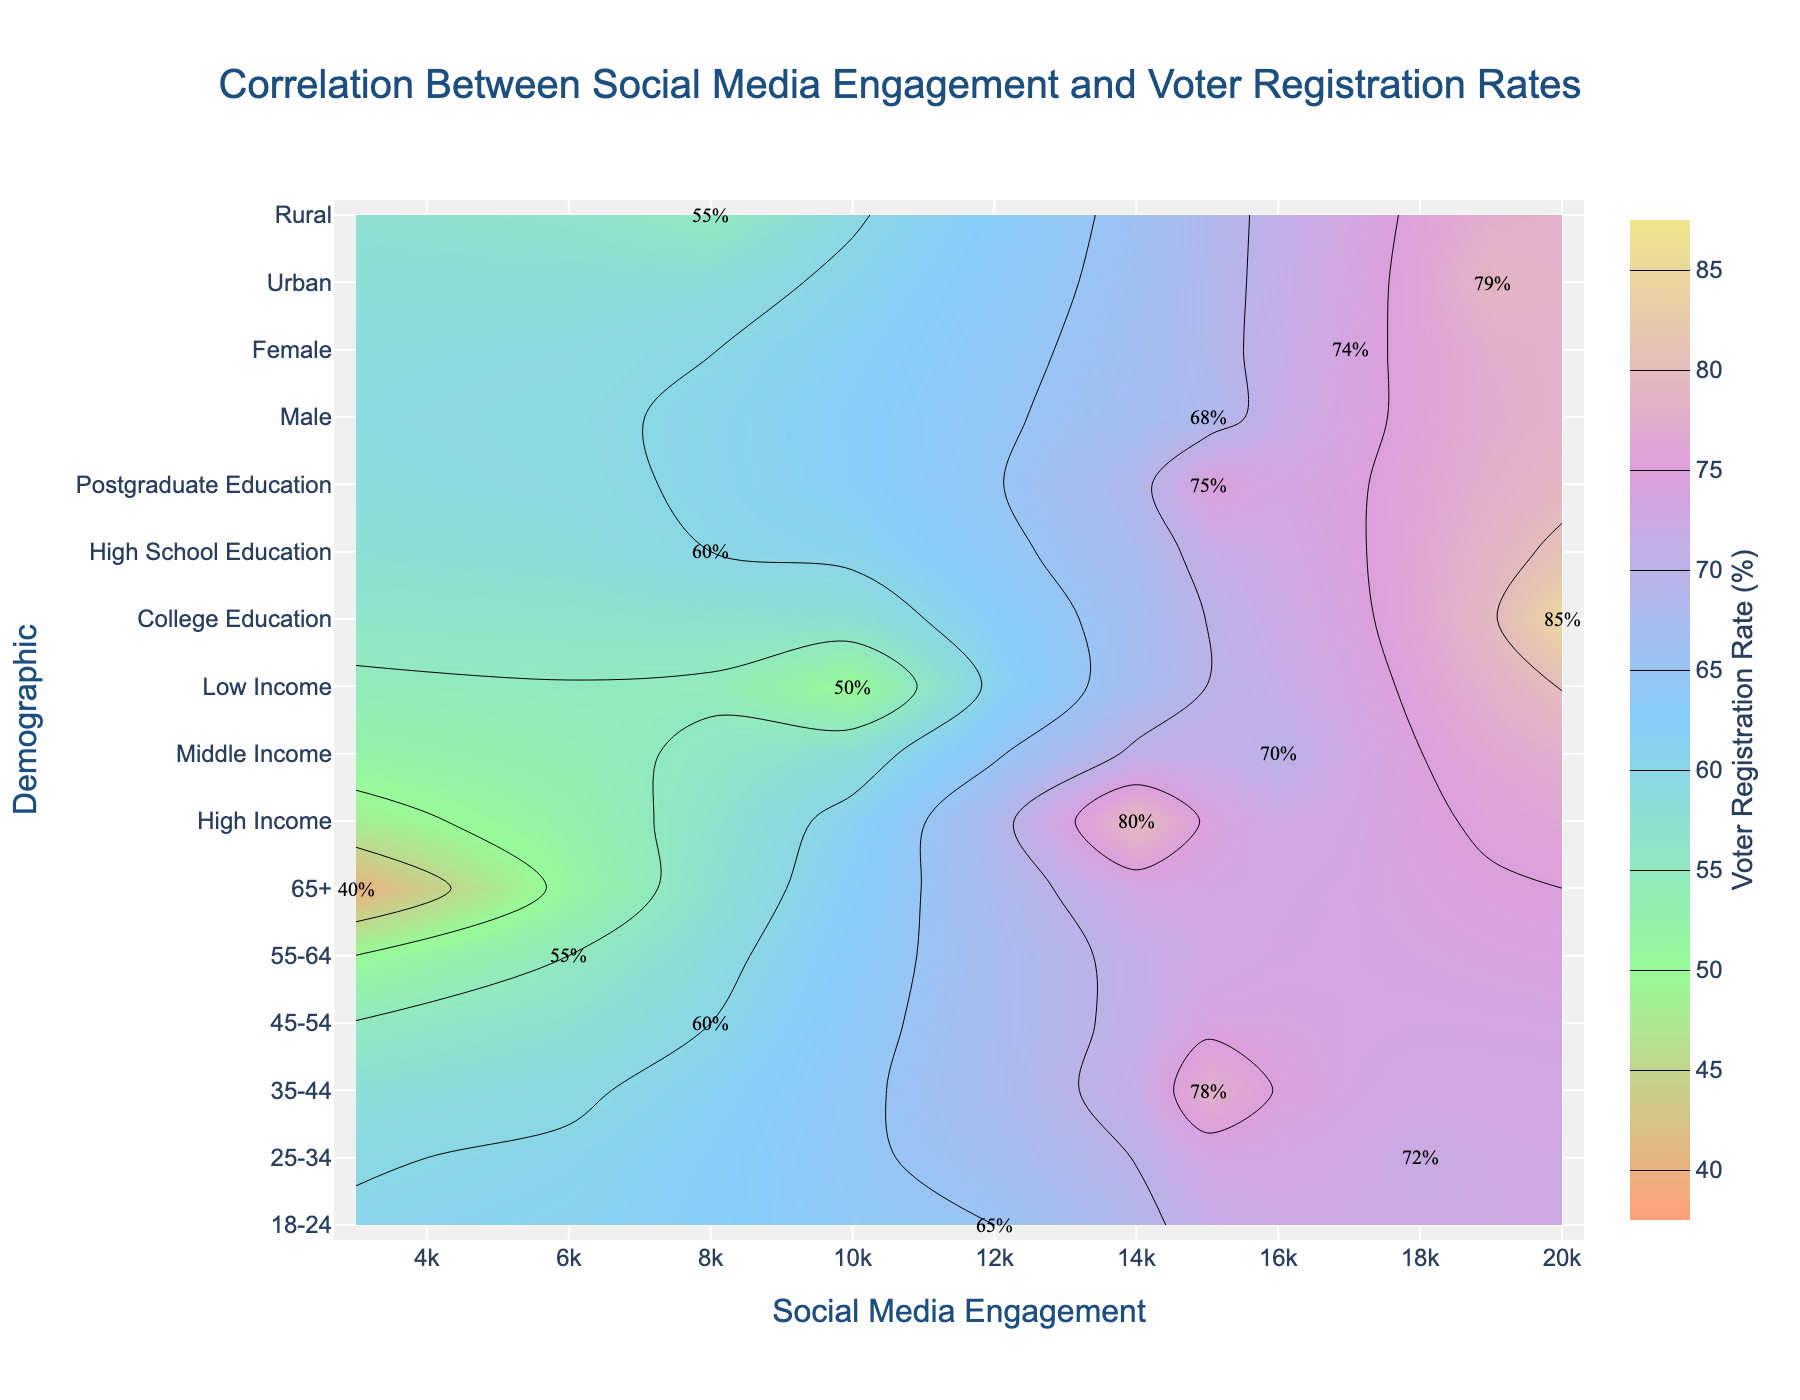What's the title of the figure? The title typically appears at the top of the figure to describe the main purpose of the plot. Here, the title is clearly placed above the plot area.
Answer: Correlation Between Social Media Engagement and Voter Registration Rates What is the color range used in the contour plot? The contour plot uses a set of colors to represent different ranges of voter registration rates, extending from light colors to dark colors to portrait the rate differences. The colors used range from light pink to light purple.
Answer: Light pink to light purple Which demographic has the highest social media engagement and what is their voter registration rate? By looking at the point that is farthest to the right on the x-axis (social media engagement), we identify the corresponding y-axis (demographic). The label at this position shows the voter registration rate. The "College Education" layer is located at the highest engagement (~20000) with a registration rate of 85%.
Answer: College Education, 85% Which demographic has the lowest voter registration rate, and what is their social media engagement? The bottommost contour level represents the lowest voter registration rate. By referring to the labels and points nearest to this contour, we identify the demographic and the social media engagement. The "65+" group has the lowest registration rate (40%) and their engagement is about 3000.
Answer: 65+, 3000 Compare the voter registration rates between Urban and Rural demographics. Locate the Urban and Rural points along the y-axis and observe their corresponding contour levels. Urban's label shows a voter registration rate of 79%, while Rural shows a rate of 55%. Thus, Urban has a higher rate than Rural.
Answer: Urban has a 79% rate, Rural has a 55% rate What is the average voter registration rate of the demographics aged 18-24, 25-34, and 35-44? Identify the registration rates for the mentioned age groups: 65% (18-24), 72% (25-34), and 78% (35-44). Sum these values and divide by the number of groups. (65 + 72 + 78) / 3 = 215 / 3.
Answer: 71.67 What's the difference in voter registration rates between High School Education and Postgraduate Education demographics? Locate the contours for "High School Education" and "Postgraduate Education" groups. High School Education has a rate of 60%, Postgraduate Education has 75%. Calculate the registration rate difference: 75% - 60%.
Answer: 15% Which income group has the highest voter registration rate and how does it compare to the Middle Income group? Find the contours corresponding to different income groups. High Income has the highest rate at 80%, Middle Income has 70%. Compare the two values: 80% - 70%.
Answer: High Income, 10% higher How does the voter registration rate for High Income compare to the age group 45-54? Check the rates for High Income (80%) and the 45-54 age group (60%). Compare the two values: 80% - 60%.
Answer: High Income is 20% higher What is the sum of social media engagement for demographics aged 45-54 and 55-64? Identify the social media engagement values for 45-54 (8000) and 55-64 (6000). Sum these values: 8000 + 6000.
Answer: 14000 